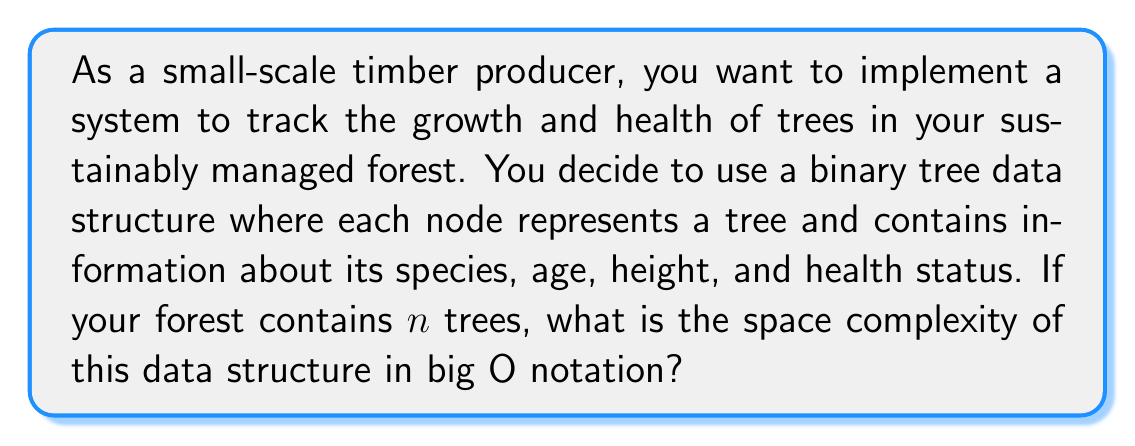Can you answer this question? To determine the space complexity of the binary tree data structure for tracking forest growth and health, we need to consider the following:

1. Each node in the binary tree represents a single tree and contains:
   - Species (string): Let's assume a fixed-length string of 20 characters
   - Age (integer): 4 bytes
   - Height (float): 4 bytes
   - Health status (enum or integer): 1 byte
   - Two pointers to child nodes: 8 bytes each (assuming 64-bit system)

2. Total space per node:
   $20 + 4 + 4 + 1 + (8 * 2) = 45$ bytes

3. The binary tree will have $n$ nodes, where $n$ is the number of trees in the forest.

4. The space complexity of a binary tree is linear with respect to the number of nodes.

Therefore, the total space required for the data structure is:

$$ \text{Total Space} = 45n \text{ bytes} $$

In big O notation, we ignore constant factors and focus on the growth rate. As the space requirement grows linearly with the number of trees, the space complexity is $O(n)$.

It's worth noting that this analysis assumes a balanced binary tree. In the worst case (a completely unbalanced tree), the space complexity would still be $O(n)$, but the constant factor might be slightly different due to potential overhead in tree implementation.
Answer: $O(n)$ 